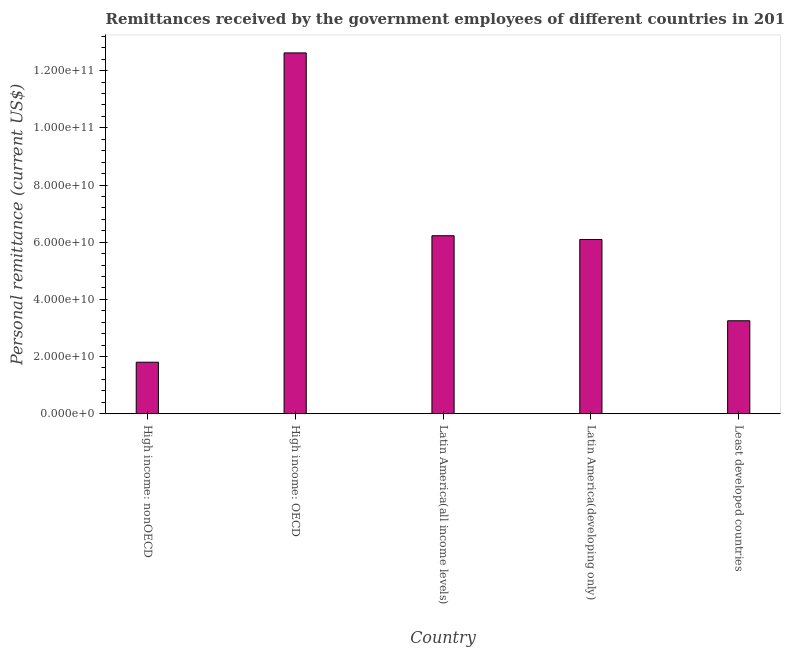Does the graph contain any zero values?
Make the answer very short. No. What is the title of the graph?
Provide a short and direct response. Remittances received by the government employees of different countries in 2013. What is the label or title of the X-axis?
Ensure brevity in your answer.  Country. What is the label or title of the Y-axis?
Ensure brevity in your answer.  Personal remittance (current US$). What is the personal remittances in Least developed countries?
Provide a succinct answer. 3.25e+1. Across all countries, what is the maximum personal remittances?
Provide a short and direct response. 1.26e+11. Across all countries, what is the minimum personal remittances?
Make the answer very short. 1.80e+1. In which country was the personal remittances maximum?
Make the answer very short. High income: OECD. In which country was the personal remittances minimum?
Your answer should be very brief. High income: nonOECD. What is the sum of the personal remittances?
Your response must be concise. 3.00e+11. What is the difference between the personal remittances in High income: OECD and High income: nonOECD?
Keep it short and to the point. 1.08e+11. What is the average personal remittances per country?
Your response must be concise. 6.00e+1. What is the median personal remittances?
Your response must be concise. 6.10e+1. In how many countries, is the personal remittances greater than 76000000000 US$?
Provide a succinct answer. 1. What is the ratio of the personal remittances in Latin America(developing only) to that in Least developed countries?
Provide a succinct answer. 1.87. Is the difference between the personal remittances in High income: nonOECD and Least developed countries greater than the difference between any two countries?
Your answer should be compact. No. What is the difference between the highest and the second highest personal remittances?
Make the answer very short. 6.39e+1. What is the difference between the highest and the lowest personal remittances?
Offer a very short reply. 1.08e+11. In how many countries, is the personal remittances greater than the average personal remittances taken over all countries?
Your response must be concise. 3. How many bars are there?
Your answer should be very brief. 5. Are all the bars in the graph horizontal?
Make the answer very short. No. How many countries are there in the graph?
Provide a short and direct response. 5. Are the values on the major ticks of Y-axis written in scientific E-notation?
Your answer should be very brief. Yes. What is the Personal remittance (current US$) of High income: nonOECD?
Provide a short and direct response. 1.80e+1. What is the Personal remittance (current US$) of High income: OECD?
Ensure brevity in your answer.  1.26e+11. What is the Personal remittance (current US$) in Latin America(all income levels)?
Give a very brief answer. 6.23e+1. What is the Personal remittance (current US$) in Latin America(developing only)?
Your answer should be compact. 6.10e+1. What is the Personal remittance (current US$) in Least developed countries?
Keep it short and to the point. 3.25e+1. What is the difference between the Personal remittance (current US$) in High income: nonOECD and High income: OECD?
Your answer should be compact. -1.08e+11. What is the difference between the Personal remittance (current US$) in High income: nonOECD and Latin America(all income levels)?
Keep it short and to the point. -4.42e+1. What is the difference between the Personal remittance (current US$) in High income: nonOECD and Latin America(developing only)?
Provide a short and direct response. -4.29e+1. What is the difference between the Personal remittance (current US$) in High income: nonOECD and Least developed countries?
Offer a terse response. -1.45e+1. What is the difference between the Personal remittance (current US$) in High income: OECD and Latin America(all income levels)?
Offer a terse response. 6.39e+1. What is the difference between the Personal remittance (current US$) in High income: OECD and Latin America(developing only)?
Provide a short and direct response. 6.53e+1. What is the difference between the Personal remittance (current US$) in High income: OECD and Least developed countries?
Offer a very short reply. 9.37e+1. What is the difference between the Personal remittance (current US$) in Latin America(all income levels) and Latin America(developing only)?
Give a very brief answer. 1.31e+09. What is the difference between the Personal remittance (current US$) in Latin America(all income levels) and Least developed countries?
Keep it short and to the point. 2.97e+1. What is the difference between the Personal remittance (current US$) in Latin America(developing only) and Least developed countries?
Provide a succinct answer. 2.84e+1. What is the ratio of the Personal remittance (current US$) in High income: nonOECD to that in High income: OECD?
Your response must be concise. 0.14. What is the ratio of the Personal remittance (current US$) in High income: nonOECD to that in Latin America(all income levels)?
Your answer should be compact. 0.29. What is the ratio of the Personal remittance (current US$) in High income: nonOECD to that in Latin America(developing only)?
Provide a short and direct response. 0.3. What is the ratio of the Personal remittance (current US$) in High income: nonOECD to that in Least developed countries?
Keep it short and to the point. 0.55. What is the ratio of the Personal remittance (current US$) in High income: OECD to that in Latin America(all income levels)?
Provide a short and direct response. 2.03. What is the ratio of the Personal remittance (current US$) in High income: OECD to that in Latin America(developing only)?
Make the answer very short. 2.07. What is the ratio of the Personal remittance (current US$) in High income: OECD to that in Least developed countries?
Ensure brevity in your answer.  3.88. What is the ratio of the Personal remittance (current US$) in Latin America(all income levels) to that in Latin America(developing only)?
Give a very brief answer. 1.02. What is the ratio of the Personal remittance (current US$) in Latin America(all income levels) to that in Least developed countries?
Provide a short and direct response. 1.92. What is the ratio of the Personal remittance (current US$) in Latin America(developing only) to that in Least developed countries?
Your answer should be compact. 1.87. 